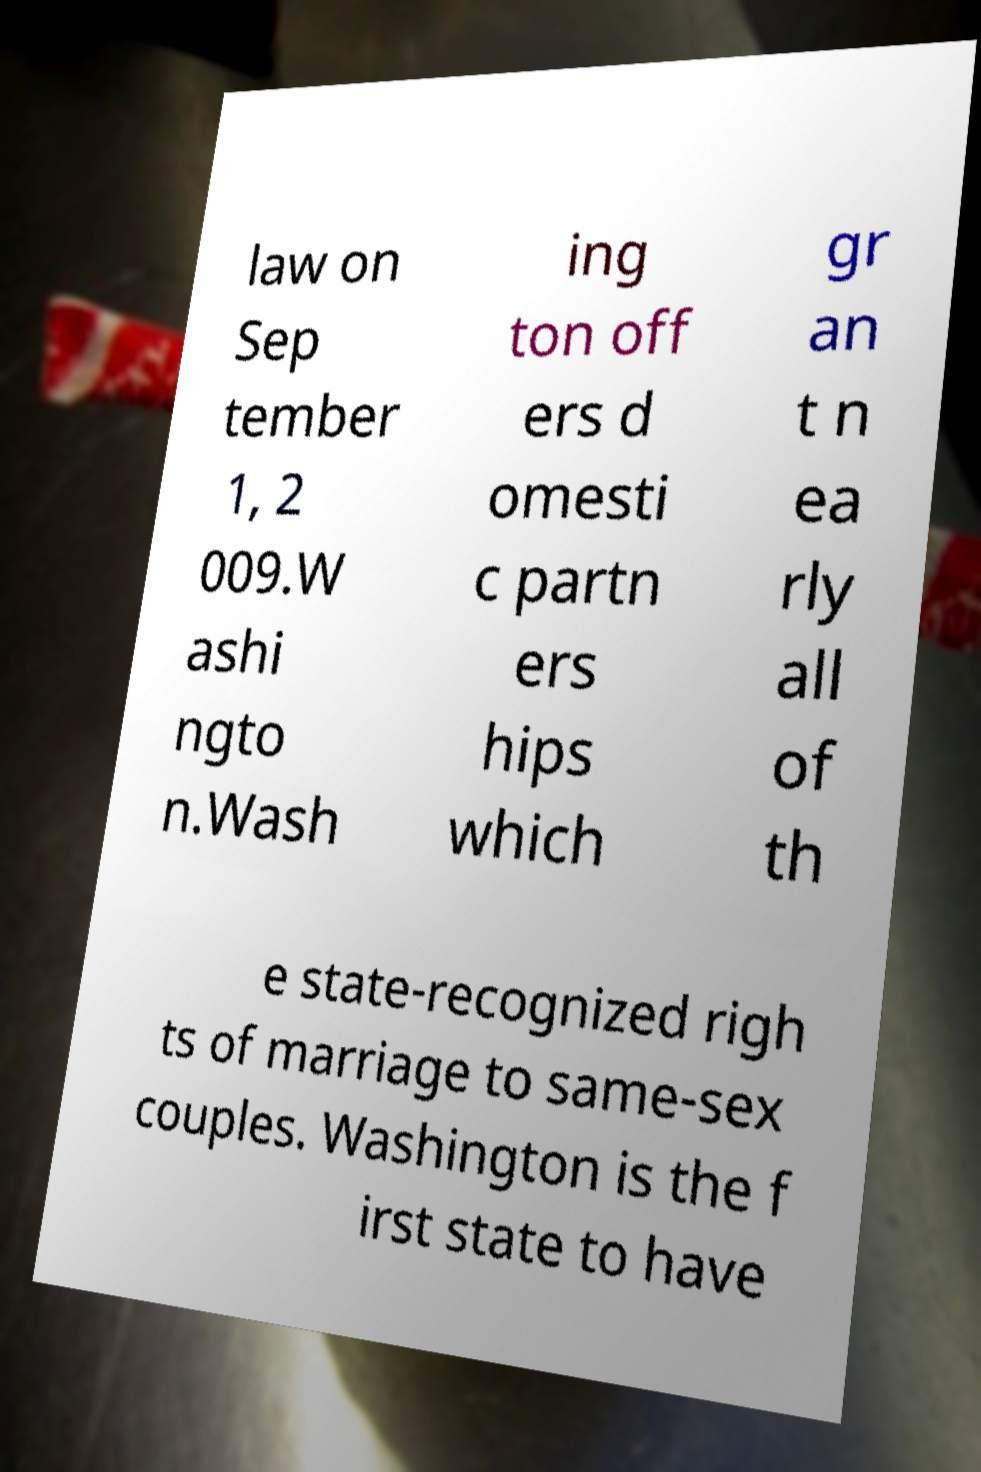Can you accurately transcribe the text from the provided image for me? law on Sep tember 1, 2 009.W ashi ngto n.Wash ing ton off ers d omesti c partn ers hips which gr an t n ea rly all of th e state-recognized righ ts of marriage to same-sex couples. Washington is the f irst state to have 